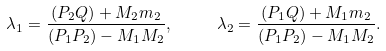Convert formula to latex. <formula><loc_0><loc_0><loc_500><loc_500>\lambda _ { 1 } = \frac { ( P _ { 2 } Q ) + M _ { 2 } m _ { 2 } } { ( P _ { 1 } P _ { 2 } ) - M _ { 1 } M _ { 2 } } , \quad \ \lambda _ { 2 } = \frac { ( P _ { 1 } Q ) + M _ { 1 } m _ { 2 } } { ( P _ { 1 } P _ { 2 } ) - M _ { 1 } M _ { 2 } } .</formula> 